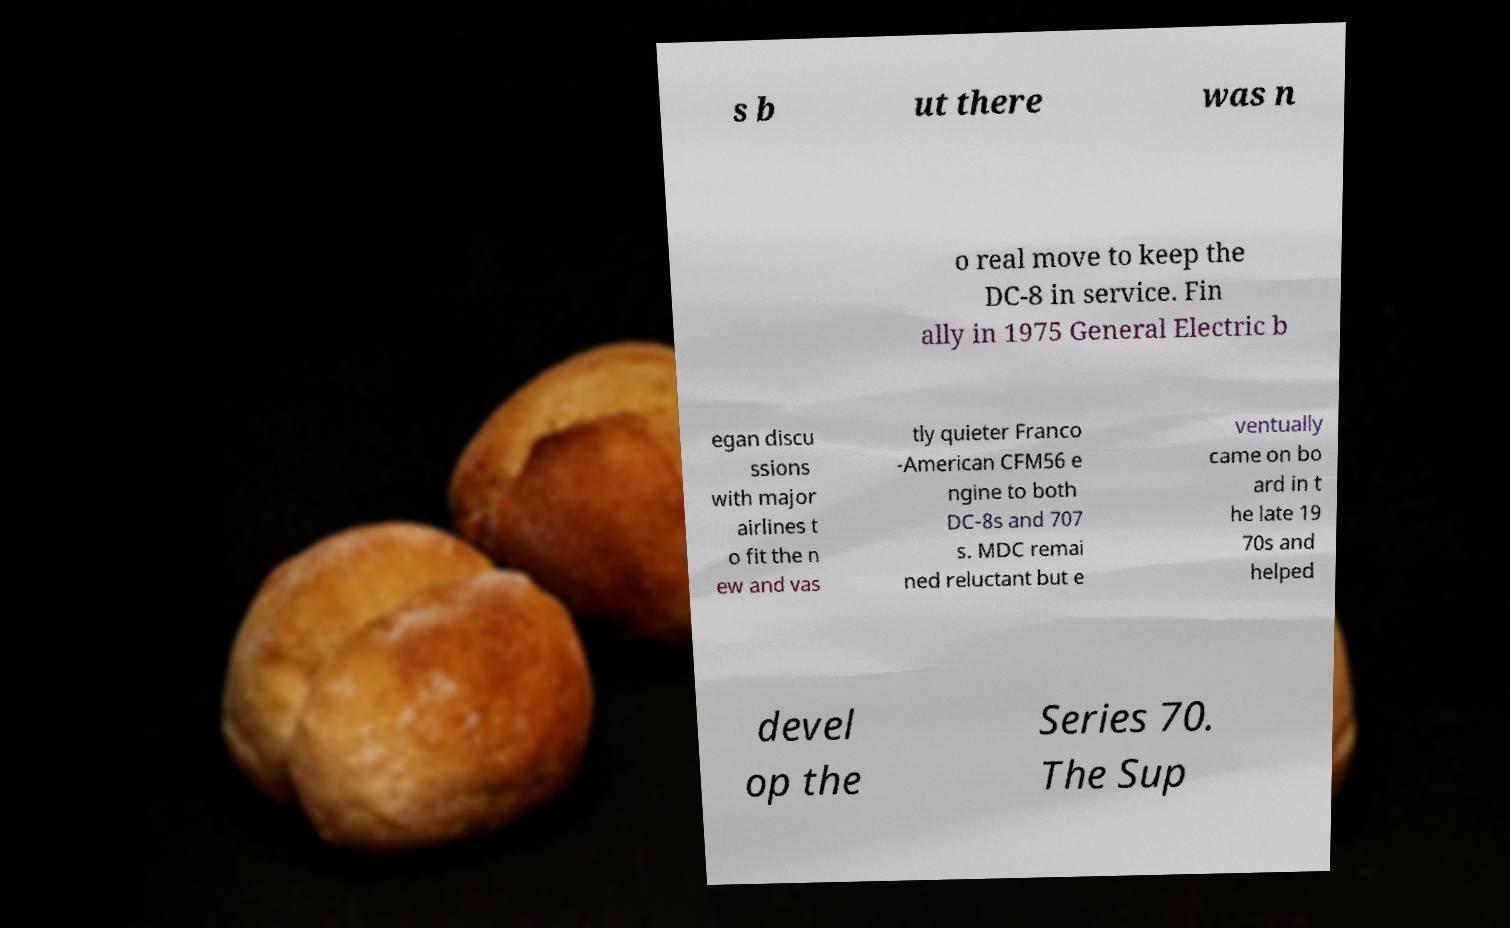Please identify and transcribe the text found in this image. s b ut there was n o real move to keep the DC-8 in service. Fin ally in 1975 General Electric b egan discu ssions with major airlines t o fit the n ew and vas tly quieter Franco -American CFM56 e ngine to both DC-8s and 707 s. MDC remai ned reluctant but e ventually came on bo ard in t he late 19 70s and helped devel op the Series 70. The Sup 